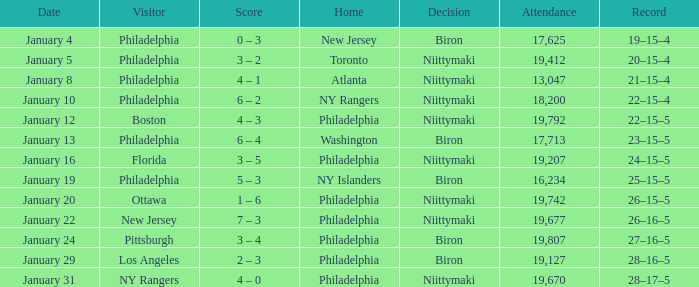Could you parse the entire table as a dict? {'header': ['Date', 'Visitor', 'Score', 'Home', 'Decision', 'Attendance', 'Record'], 'rows': [['January 4', 'Philadelphia', '0 – 3', 'New Jersey', 'Biron', '17,625', '19–15–4'], ['January 5', 'Philadelphia', '3 – 2', 'Toronto', 'Niittymaki', '19,412', '20–15–4'], ['January 8', 'Philadelphia', '4 – 1', 'Atlanta', 'Niittymaki', '13,047', '21–15–4'], ['January 10', 'Philadelphia', '6 – 2', 'NY Rangers', 'Niittymaki', '18,200', '22–15–4'], ['January 12', 'Boston', '4 – 3', 'Philadelphia', 'Niittymaki', '19,792', '22–15–5'], ['January 13', 'Philadelphia', '6 – 4', 'Washington', 'Biron', '17,713', '23–15–5'], ['January 16', 'Florida', '3 – 5', 'Philadelphia', 'Niittymaki', '19,207', '24–15–5'], ['January 19', 'Philadelphia', '5 – 3', 'NY Islanders', 'Biron', '16,234', '25–15–5'], ['January 20', 'Ottawa', '1 – 6', 'Philadelphia', 'Niittymaki', '19,742', '26–15–5'], ['January 22', 'New Jersey', '7 – 3', 'Philadelphia', 'Niittymaki', '19,677', '26–16–5'], ['January 24', 'Pittsburgh', '3 – 4', 'Philadelphia', 'Biron', '19,807', '27–16–5'], ['January 29', 'Los Angeles', '2 – 3', 'Philadelphia', 'Biron', '19,127', '28–16–5'], ['January 31', 'NY Rangers', '4 – 0', 'Philadelphia', 'Niittymaki', '19,670', '28–17–5']]} On which date did the resolution concern niittymaki, the audience exceeded 19,207, and the record stood at 28-17-5? January 31. 